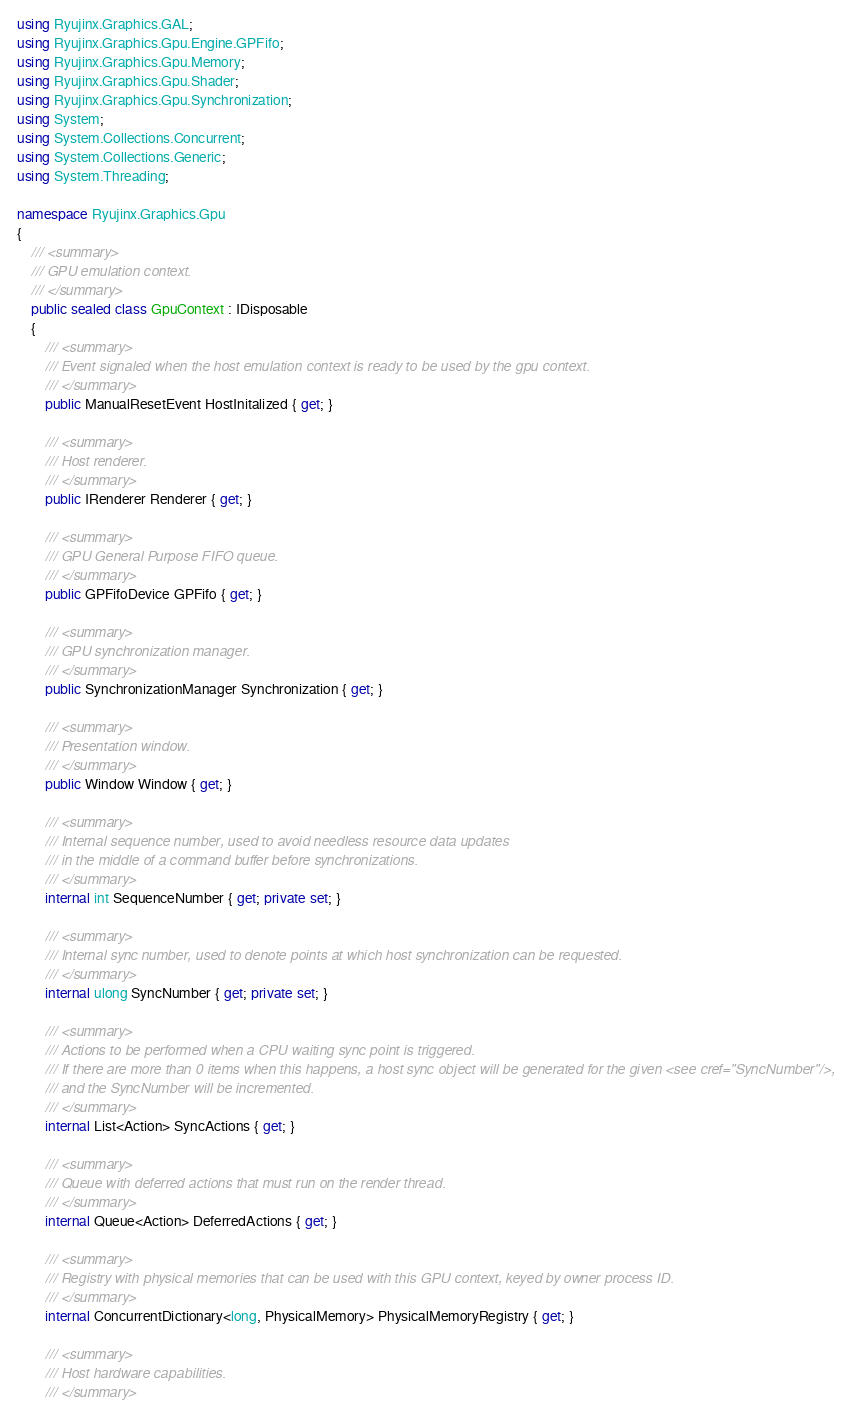<code> <loc_0><loc_0><loc_500><loc_500><_C#_>using Ryujinx.Graphics.GAL;
using Ryujinx.Graphics.Gpu.Engine.GPFifo;
using Ryujinx.Graphics.Gpu.Memory;
using Ryujinx.Graphics.Gpu.Shader;
using Ryujinx.Graphics.Gpu.Synchronization;
using System;
using System.Collections.Concurrent;
using System.Collections.Generic;
using System.Threading;

namespace Ryujinx.Graphics.Gpu
{
    /// <summary>
    /// GPU emulation context.
    /// </summary>
    public sealed class GpuContext : IDisposable
    {
        /// <summary>
        /// Event signaled when the host emulation context is ready to be used by the gpu context.
        /// </summary>
        public ManualResetEvent HostInitalized { get; }

        /// <summary>
        /// Host renderer.
        /// </summary>
        public IRenderer Renderer { get; }

        /// <summary>
        /// GPU General Purpose FIFO queue.
        /// </summary>
        public GPFifoDevice GPFifo { get; }

        /// <summary>
        /// GPU synchronization manager.
        /// </summary>
        public SynchronizationManager Synchronization { get; }

        /// <summary>
        /// Presentation window.
        /// </summary>
        public Window Window { get; }

        /// <summary>
        /// Internal sequence number, used to avoid needless resource data updates
        /// in the middle of a command buffer before synchronizations.
        /// </summary>
        internal int SequenceNumber { get; private set; }

        /// <summary>
        /// Internal sync number, used to denote points at which host synchronization can be requested.
        /// </summary>
        internal ulong SyncNumber { get; private set; }

        /// <summary>
        /// Actions to be performed when a CPU waiting sync point is triggered.
        /// If there are more than 0 items when this happens, a host sync object will be generated for the given <see cref="SyncNumber"/>,
        /// and the SyncNumber will be incremented.
        /// </summary>
        internal List<Action> SyncActions { get; }

        /// <summary>
        /// Queue with deferred actions that must run on the render thread.
        /// </summary>
        internal Queue<Action> DeferredActions { get; }

        /// <summary>
        /// Registry with physical memories that can be used with this GPU context, keyed by owner process ID.
        /// </summary>
        internal ConcurrentDictionary<long, PhysicalMemory> PhysicalMemoryRegistry { get; }

        /// <summary>
        /// Host hardware capabilities.
        /// </summary></code> 